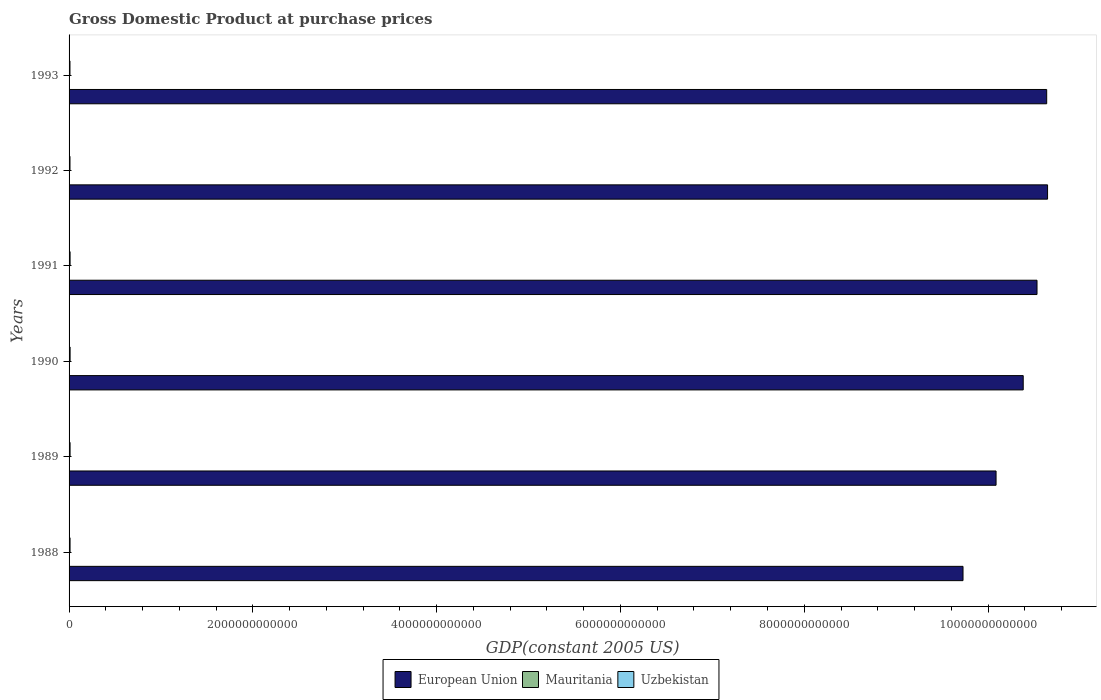Are the number of bars per tick equal to the number of legend labels?
Make the answer very short. Yes. Are the number of bars on each tick of the Y-axis equal?
Your response must be concise. Yes. How many bars are there on the 6th tick from the bottom?
Provide a short and direct response. 3. What is the GDP at purchase prices in European Union in 1988?
Ensure brevity in your answer.  9.73e+12. Across all years, what is the maximum GDP at purchase prices in European Union?
Give a very brief answer. 1.06e+13. Across all years, what is the minimum GDP at purchase prices in European Union?
Offer a very short reply. 9.73e+12. In which year was the GDP at purchase prices in Uzbekistan maximum?
Your answer should be very brief. 1990. What is the total GDP at purchase prices in European Union in the graph?
Keep it short and to the point. 6.20e+13. What is the difference between the GDP at purchase prices in European Union in 1989 and that in 1993?
Give a very brief answer. -5.51e+11. What is the difference between the GDP at purchase prices in Mauritania in 1990 and the GDP at purchase prices in European Union in 1993?
Your answer should be compact. -1.06e+13. What is the average GDP at purchase prices in European Union per year?
Offer a very short reply. 1.03e+13. In the year 1992, what is the difference between the GDP at purchase prices in European Union and GDP at purchase prices in Mauritania?
Provide a succinct answer. 1.06e+13. In how many years, is the GDP at purchase prices in European Union greater than 1200000000000 US$?
Make the answer very short. 6. What is the ratio of the GDP at purchase prices in Uzbekistan in 1990 to that in 1992?
Keep it short and to the point. 1.13. Is the GDP at purchase prices in Uzbekistan in 1988 less than that in 1992?
Your response must be concise. No. Is the difference between the GDP at purchase prices in European Union in 1991 and 1992 greater than the difference between the GDP at purchase prices in Mauritania in 1991 and 1992?
Offer a terse response. No. What is the difference between the highest and the second highest GDP at purchase prices in European Union?
Provide a short and direct response. 9.57e+09. What is the difference between the highest and the lowest GDP at purchase prices in Uzbekistan?
Make the answer very short. 1.53e+09. Is the sum of the GDP at purchase prices in Uzbekistan in 1988 and 1990 greater than the maximum GDP at purchase prices in Mauritania across all years?
Ensure brevity in your answer.  Yes. What does the 1st bar from the top in 1988 represents?
Your response must be concise. Uzbekistan. What does the 1st bar from the bottom in 1988 represents?
Ensure brevity in your answer.  European Union. Are all the bars in the graph horizontal?
Your response must be concise. Yes. How many years are there in the graph?
Your answer should be compact. 6. What is the difference between two consecutive major ticks on the X-axis?
Your answer should be compact. 2.00e+12. Where does the legend appear in the graph?
Provide a succinct answer. Bottom center. How are the legend labels stacked?
Your answer should be compact. Horizontal. What is the title of the graph?
Your response must be concise. Gross Domestic Product at purchase prices. What is the label or title of the X-axis?
Make the answer very short. GDP(constant 2005 US). What is the label or title of the Y-axis?
Offer a very short reply. Years. What is the GDP(constant 2005 US) in European Union in 1988?
Your answer should be very brief. 9.73e+12. What is the GDP(constant 2005 US) of Mauritania in 1988?
Offer a very short reply. 1.29e+09. What is the GDP(constant 2005 US) of Uzbekistan in 1988?
Your answer should be compact. 1.07e+1. What is the GDP(constant 2005 US) of European Union in 1989?
Ensure brevity in your answer.  1.01e+13. What is the GDP(constant 2005 US) in Mauritania in 1989?
Give a very brief answer. 1.36e+09. What is the GDP(constant 2005 US) of Uzbekistan in 1989?
Give a very brief answer. 1.10e+1. What is the GDP(constant 2005 US) in European Union in 1990?
Offer a terse response. 1.04e+13. What is the GDP(constant 2005 US) of Mauritania in 1990?
Make the answer very short. 1.33e+09. What is the GDP(constant 2005 US) of Uzbekistan in 1990?
Offer a terse response. 1.12e+1. What is the GDP(constant 2005 US) in European Union in 1991?
Provide a succinct answer. 1.05e+13. What is the GDP(constant 2005 US) of Mauritania in 1991?
Offer a terse response. 1.36e+09. What is the GDP(constant 2005 US) of Uzbekistan in 1991?
Offer a very short reply. 1.12e+1. What is the GDP(constant 2005 US) in European Union in 1992?
Provide a succinct answer. 1.06e+13. What is the GDP(constant 2005 US) in Mauritania in 1992?
Provide a short and direct response. 1.38e+09. What is the GDP(constant 2005 US) in Uzbekistan in 1992?
Your answer should be very brief. 9.92e+09. What is the GDP(constant 2005 US) in European Union in 1993?
Your answer should be very brief. 1.06e+13. What is the GDP(constant 2005 US) of Mauritania in 1993?
Keep it short and to the point. 1.46e+09. What is the GDP(constant 2005 US) in Uzbekistan in 1993?
Provide a short and direct response. 9.69e+09. Across all years, what is the maximum GDP(constant 2005 US) of European Union?
Keep it short and to the point. 1.06e+13. Across all years, what is the maximum GDP(constant 2005 US) of Mauritania?
Make the answer very short. 1.46e+09. Across all years, what is the maximum GDP(constant 2005 US) in Uzbekistan?
Your response must be concise. 1.12e+1. Across all years, what is the minimum GDP(constant 2005 US) in European Union?
Ensure brevity in your answer.  9.73e+12. Across all years, what is the minimum GDP(constant 2005 US) in Mauritania?
Provide a succinct answer. 1.29e+09. Across all years, what is the minimum GDP(constant 2005 US) of Uzbekistan?
Offer a terse response. 9.69e+09. What is the total GDP(constant 2005 US) in European Union in the graph?
Provide a succinct answer. 6.20e+13. What is the total GDP(constant 2005 US) of Mauritania in the graph?
Your answer should be compact. 8.18e+09. What is the total GDP(constant 2005 US) of Uzbekistan in the graph?
Your answer should be very brief. 6.37e+1. What is the difference between the GDP(constant 2005 US) in European Union in 1988 and that in 1989?
Give a very brief answer. -3.60e+11. What is the difference between the GDP(constant 2005 US) of Mauritania in 1988 and that in 1989?
Your answer should be very brief. -6.18e+07. What is the difference between the GDP(constant 2005 US) of Uzbekistan in 1988 and that in 1989?
Your response must be concise. -3.31e+08. What is the difference between the GDP(constant 2005 US) of European Union in 1988 and that in 1990?
Your response must be concise. -6.55e+11. What is the difference between the GDP(constant 2005 US) of Mauritania in 1988 and that in 1990?
Provide a short and direct response. -3.78e+07. What is the difference between the GDP(constant 2005 US) in Uzbekistan in 1988 and that in 1990?
Your response must be concise. -5.08e+08. What is the difference between the GDP(constant 2005 US) of European Union in 1988 and that in 1991?
Your answer should be compact. -8.05e+11. What is the difference between the GDP(constant 2005 US) in Mauritania in 1988 and that in 1991?
Make the answer very short. -6.16e+07. What is the difference between the GDP(constant 2005 US) in Uzbekistan in 1988 and that in 1991?
Keep it short and to the point. -4.53e+08. What is the difference between the GDP(constant 2005 US) in European Union in 1988 and that in 1992?
Give a very brief answer. -9.20e+11. What is the difference between the GDP(constant 2005 US) of Mauritania in 1988 and that in 1992?
Your answer should be very brief. -8.70e+07. What is the difference between the GDP(constant 2005 US) in Uzbekistan in 1988 and that in 1992?
Offer a very short reply. 7.98e+08. What is the difference between the GDP(constant 2005 US) in European Union in 1988 and that in 1993?
Offer a terse response. -9.10e+11. What is the difference between the GDP(constant 2005 US) of Mauritania in 1988 and that in 1993?
Offer a very short reply. -1.68e+08. What is the difference between the GDP(constant 2005 US) in Uzbekistan in 1988 and that in 1993?
Provide a short and direct response. 1.03e+09. What is the difference between the GDP(constant 2005 US) in European Union in 1989 and that in 1990?
Offer a terse response. -2.95e+11. What is the difference between the GDP(constant 2005 US) in Mauritania in 1989 and that in 1990?
Your response must be concise. 2.40e+07. What is the difference between the GDP(constant 2005 US) of Uzbekistan in 1989 and that in 1990?
Your answer should be very brief. -1.77e+08. What is the difference between the GDP(constant 2005 US) in European Union in 1989 and that in 1991?
Offer a very short reply. -4.46e+11. What is the difference between the GDP(constant 2005 US) in Mauritania in 1989 and that in 1991?
Your answer should be compact. 2.02e+05. What is the difference between the GDP(constant 2005 US) of Uzbekistan in 1989 and that in 1991?
Your answer should be very brief. -1.22e+08. What is the difference between the GDP(constant 2005 US) of European Union in 1989 and that in 1992?
Provide a succinct answer. -5.60e+11. What is the difference between the GDP(constant 2005 US) in Mauritania in 1989 and that in 1992?
Offer a terse response. -2.52e+07. What is the difference between the GDP(constant 2005 US) in Uzbekistan in 1989 and that in 1992?
Give a very brief answer. 1.13e+09. What is the difference between the GDP(constant 2005 US) in European Union in 1989 and that in 1993?
Keep it short and to the point. -5.51e+11. What is the difference between the GDP(constant 2005 US) of Mauritania in 1989 and that in 1993?
Give a very brief answer. -1.06e+08. What is the difference between the GDP(constant 2005 US) in Uzbekistan in 1989 and that in 1993?
Your response must be concise. 1.36e+09. What is the difference between the GDP(constant 2005 US) of European Union in 1990 and that in 1991?
Ensure brevity in your answer.  -1.50e+11. What is the difference between the GDP(constant 2005 US) in Mauritania in 1990 and that in 1991?
Provide a short and direct response. -2.38e+07. What is the difference between the GDP(constant 2005 US) of Uzbekistan in 1990 and that in 1991?
Offer a terse response. 5.52e+07. What is the difference between the GDP(constant 2005 US) in European Union in 1990 and that in 1992?
Your response must be concise. -2.65e+11. What is the difference between the GDP(constant 2005 US) of Mauritania in 1990 and that in 1992?
Your answer should be compact. -4.92e+07. What is the difference between the GDP(constant 2005 US) of Uzbekistan in 1990 and that in 1992?
Offer a terse response. 1.31e+09. What is the difference between the GDP(constant 2005 US) of European Union in 1990 and that in 1993?
Provide a short and direct response. -2.55e+11. What is the difference between the GDP(constant 2005 US) in Mauritania in 1990 and that in 1993?
Give a very brief answer. -1.30e+08. What is the difference between the GDP(constant 2005 US) of Uzbekistan in 1990 and that in 1993?
Your answer should be very brief. 1.53e+09. What is the difference between the GDP(constant 2005 US) of European Union in 1991 and that in 1992?
Your answer should be compact. -1.15e+11. What is the difference between the GDP(constant 2005 US) of Mauritania in 1991 and that in 1992?
Provide a succinct answer. -2.54e+07. What is the difference between the GDP(constant 2005 US) in Uzbekistan in 1991 and that in 1992?
Provide a succinct answer. 1.25e+09. What is the difference between the GDP(constant 2005 US) of European Union in 1991 and that in 1993?
Keep it short and to the point. -1.05e+11. What is the difference between the GDP(constant 2005 US) in Mauritania in 1991 and that in 1993?
Offer a very short reply. -1.07e+08. What is the difference between the GDP(constant 2005 US) of Uzbekistan in 1991 and that in 1993?
Your response must be concise. 1.48e+09. What is the difference between the GDP(constant 2005 US) in European Union in 1992 and that in 1993?
Make the answer very short. 9.57e+09. What is the difference between the GDP(constant 2005 US) in Mauritania in 1992 and that in 1993?
Provide a succinct answer. -8.11e+07. What is the difference between the GDP(constant 2005 US) in Uzbekistan in 1992 and that in 1993?
Ensure brevity in your answer.  2.28e+08. What is the difference between the GDP(constant 2005 US) of European Union in 1988 and the GDP(constant 2005 US) of Mauritania in 1989?
Give a very brief answer. 9.73e+12. What is the difference between the GDP(constant 2005 US) of European Union in 1988 and the GDP(constant 2005 US) of Uzbekistan in 1989?
Keep it short and to the point. 9.72e+12. What is the difference between the GDP(constant 2005 US) in Mauritania in 1988 and the GDP(constant 2005 US) in Uzbekistan in 1989?
Make the answer very short. -9.75e+09. What is the difference between the GDP(constant 2005 US) in European Union in 1988 and the GDP(constant 2005 US) in Mauritania in 1990?
Give a very brief answer. 9.73e+12. What is the difference between the GDP(constant 2005 US) in European Union in 1988 and the GDP(constant 2005 US) in Uzbekistan in 1990?
Give a very brief answer. 9.72e+12. What is the difference between the GDP(constant 2005 US) of Mauritania in 1988 and the GDP(constant 2005 US) of Uzbekistan in 1990?
Offer a terse response. -9.93e+09. What is the difference between the GDP(constant 2005 US) in European Union in 1988 and the GDP(constant 2005 US) in Mauritania in 1991?
Your response must be concise. 9.73e+12. What is the difference between the GDP(constant 2005 US) of European Union in 1988 and the GDP(constant 2005 US) of Uzbekistan in 1991?
Your answer should be very brief. 9.72e+12. What is the difference between the GDP(constant 2005 US) of Mauritania in 1988 and the GDP(constant 2005 US) of Uzbekistan in 1991?
Your response must be concise. -9.87e+09. What is the difference between the GDP(constant 2005 US) in European Union in 1988 and the GDP(constant 2005 US) in Mauritania in 1992?
Offer a terse response. 9.73e+12. What is the difference between the GDP(constant 2005 US) in European Union in 1988 and the GDP(constant 2005 US) in Uzbekistan in 1992?
Give a very brief answer. 9.72e+12. What is the difference between the GDP(constant 2005 US) in Mauritania in 1988 and the GDP(constant 2005 US) in Uzbekistan in 1992?
Keep it short and to the point. -8.62e+09. What is the difference between the GDP(constant 2005 US) in European Union in 1988 and the GDP(constant 2005 US) in Mauritania in 1993?
Your answer should be compact. 9.73e+12. What is the difference between the GDP(constant 2005 US) in European Union in 1988 and the GDP(constant 2005 US) in Uzbekistan in 1993?
Your answer should be compact. 9.72e+12. What is the difference between the GDP(constant 2005 US) in Mauritania in 1988 and the GDP(constant 2005 US) in Uzbekistan in 1993?
Your answer should be compact. -8.39e+09. What is the difference between the GDP(constant 2005 US) in European Union in 1989 and the GDP(constant 2005 US) in Mauritania in 1990?
Your answer should be compact. 1.01e+13. What is the difference between the GDP(constant 2005 US) of European Union in 1989 and the GDP(constant 2005 US) of Uzbekistan in 1990?
Make the answer very short. 1.01e+13. What is the difference between the GDP(constant 2005 US) in Mauritania in 1989 and the GDP(constant 2005 US) in Uzbekistan in 1990?
Ensure brevity in your answer.  -9.87e+09. What is the difference between the GDP(constant 2005 US) in European Union in 1989 and the GDP(constant 2005 US) in Mauritania in 1991?
Offer a terse response. 1.01e+13. What is the difference between the GDP(constant 2005 US) of European Union in 1989 and the GDP(constant 2005 US) of Uzbekistan in 1991?
Ensure brevity in your answer.  1.01e+13. What is the difference between the GDP(constant 2005 US) of Mauritania in 1989 and the GDP(constant 2005 US) of Uzbekistan in 1991?
Your response must be concise. -9.81e+09. What is the difference between the GDP(constant 2005 US) of European Union in 1989 and the GDP(constant 2005 US) of Mauritania in 1992?
Your answer should be very brief. 1.01e+13. What is the difference between the GDP(constant 2005 US) in European Union in 1989 and the GDP(constant 2005 US) in Uzbekistan in 1992?
Ensure brevity in your answer.  1.01e+13. What is the difference between the GDP(constant 2005 US) of Mauritania in 1989 and the GDP(constant 2005 US) of Uzbekistan in 1992?
Provide a short and direct response. -8.56e+09. What is the difference between the GDP(constant 2005 US) in European Union in 1989 and the GDP(constant 2005 US) in Mauritania in 1993?
Offer a terse response. 1.01e+13. What is the difference between the GDP(constant 2005 US) of European Union in 1989 and the GDP(constant 2005 US) of Uzbekistan in 1993?
Keep it short and to the point. 1.01e+13. What is the difference between the GDP(constant 2005 US) in Mauritania in 1989 and the GDP(constant 2005 US) in Uzbekistan in 1993?
Your answer should be very brief. -8.33e+09. What is the difference between the GDP(constant 2005 US) in European Union in 1990 and the GDP(constant 2005 US) in Mauritania in 1991?
Offer a very short reply. 1.04e+13. What is the difference between the GDP(constant 2005 US) of European Union in 1990 and the GDP(constant 2005 US) of Uzbekistan in 1991?
Make the answer very short. 1.04e+13. What is the difference between the GDP(constant 2005 US) in Mauritania in 1990 and the GDP(constant 2005 US) in Uzbekistan in 1991?
Offer a very short reply. -9.83e+09. What is the difference between the GDP(constant 2005 US) in European Union in 1990 and the GDP(constant 2005 US) in Mauritania in 1992?
Offer a terse response. 1.04e+13. What is the difference between the GDP(constant 2005 US) of European Union in 1990 and the GDP(constant 2005 US) of Uzbekistan in 1992?
Give a very brief answer. 1.04e+13. What is the difference between the GDP(constant 2005 US) in Mauritania in 1990 and the GDP(constant 2005 US) in Uzbekistan in 1992?
Ensure brevity in your answer.  -8.58e+09. What is the difference between the GDP(constant 2005 US) in European Union in 1990 and the GDP(constant 2005 US) in Mauritania in 1993?
Keep it short and to the point. 1.04e+13. What is the difference between the GDP(constant 2005 US) in European Union in 1990 and the GDP(constant 2005 US) in Uzbekistan in 1993?
Keep it short and to the point. 1.04e+13. What is the difference between the GDP(constant 2005 US) of Mauritania in 1990 and the GDP(constant 2005 US) of Uzbekistan in 1993?
Your answer should be very brief. -8.36e+09. What is the difference between the GDP(constant 2005 US) in European Union in 1991 and the GDP(constant 2005 US) in Mauritania in 1992?
Your response must be concise. 1.05e+13. What is the difference between the GDP(constant 2005 US) of European Union in 1991 and the GDP(constant 2005 US) of Uzbekistan in 1992?
Your answer should be very brief. 1.05e+13. What is the difference between the GDP(constant 2005 US) in Mauritania in 1991 and the GDP(constant 2005 US) in Uzbekistan in 1992?
Your answer should be very brief. -8.56e+09. What is the difference between the GDP(constant 2005 US) of European Union in 1991 and the GDP(constant 2005 US) of Mauritania in 1993?
Offer a terse response. 1.05e+13. What is the difference between the GDP(constant 2005 US) in European Union in 1991 and the GDP(constant 2005 US) in Uzbekistan in 1993?
Keep it short and to the point. 1.05e+13. What is the difference between the GDP(constant 2005 US) in Mauritania in 1991 and the GDP(constant 2005 US) in Uzbekistan in 1993?
Provide a succinct answer. -8.33e+09. What is the difference between the GDP(constant 2005 US) in European Union in 1992 and the GDP(constant 2005 US) in Mauritania in 1993?
Keep it short and to the point. 1.06e+13. What is the difference between the GDP(constant 2005 US) in European Union in 1992 and the GDP(constant 2005 US) in Uzbekistan in 1993?
Your answer should be compact. 1.06e+13. What is the difference between the GDP(constant 2005 US) in Mauritania in 1992 and the GDP(constant 2005 US) in Uzbekistan in 1993?
Provide a short and direct response. -8.31e+09. What is the average GDP(constant 2005 US) in European Union per year?
Ensure brevity in your answer.  1.03e+13. What is the average GDP(constant 2005 US) in Mauritania per year?
Your answer should be compact. 1.36e+09. What is the average GDP(constant 2005 US) of Uzbekistan per year?
Offer a terse response. 1.06e+1. In the year 1988, what is the difference between the GDP(constant 2005 US) in European Union and GDP(constant 2005 US) in Mauritania?
Make the answer very short. 9.73e+12. In the year 1988, what is the difference between the GDP(constant 2005 US) in European Union and GDP(constant 2005 US) in Uzbekistan?
Offer a terse response. 9.72e+12. In the year 1988, what is the difference between the GDP(constant 2005 US) in Mauritania and GDP(constant 2005 US) in Uzbekistan?
Offer a very short reply. -9.42e+09. In the year 1989, what is the difference between the GDP(constant 2005 US) of European Union and GDP(constant 2005 US) of Mauritania?
Your answer should be very brief. 1.01e+13. In the year 1989, what is the difference between the GDP(constant 2005 US) of European Union and GDP(constant 2005 US) of Uzbekistan?
Keep it short and to the point. 1.01e+13. In the year 1989, what is the difference between the GDP(constant 2005 US) in Mauritania and GDP(constant 2005 US) in Uzbekistan?
Offer a very short reply. -9.69e+09. In the year 1990, what is the difference between the GDP(constant 2005 US) in European Union and GDP(constant 2005 US) in Mauritania?
Provide a short and direct response. 1.04e+13. In the year 1990, what is the difference between the GDP(constant 2005 US) in European Union and GDP(constant 2005 US) in Uzbekistan?
Make the answer very short. 1.04e+13. In the year 1990, what is the difference between the GDP(constant 2005 US) in Mauritania and GDP(constant 2005 US) in Uzbekistan?
Make the answer very short. -9.89e+09. In the year 1991, what is the difference between the GDP(constant 2005 US) in European Union and GDP(constant 2005 US) in Mauritania?
Keep it short and to the point. 1.05e+13. In the year 1991, what is the difference between the GDP(constant 2005 US) in European Union and GDP(constant 2005 US) in Uzbekistan?
Give a very brief answer. 1.05e+13. In the year 1991, what is the difference between the GDP(constant 2005 US) of Mauritania and GDP(constant 2005 US) of Uzbekistan?
Keep it short and to the point. -9.81e+09. In the year 1992, what is the difference between the GDP(constant 2005 US) of European Union and GDP(constant 2005 US) of Mauritania?
Provide a succinct answer. 1.06e+13. In the year 1992, what is the difference between the GDP(constant 2005 US) in European Union and GDP(constant 2005 US) in Uzbekistan?
Ensure brevity in your answer.  1.06e+13. In the year 1992, what is the difference between the GDP(constant 2005 US) of Mauritania and GDP(constant 2005 US) of Uzbekistan?
Your response must be concise. -8.53e+09. In the year 1993, what is the difference between the GDP(constant 2005 US) in European Union and GDP(constant 2005 US) in Mauritania?
Your response must be concise. 1.06e+13. In the year 1993, what is the difference between the GDP(constant 2005 US) of European Union and GDP(constant 2005 US) of Uzbekistan?
Provide a short and direct response. 1.06e+13. In the year 1993, what is the difference between the GDP(constant 2005 US) in Mauritania and GDP(constant 2005 US) in Uzbekistan?
Your answer should be very brief. -8.23e+09. What is the ratio of the GDP(constant 2005 US) of European Union in 1988 to that in 1989?
Make the answer very short. 0.96. What is the ratio of the GDP(constant 2005 US) of Mauritania in 1988 to that in 1989?
Your response must be concise. 0.95. What is the ratio of the GDP(constant 2005 US) in Uzbekistan in 1988 to that in 1989?
Offer a very short reply. 0.97. What is the ratio of the GDP(constant 2005 US) of European Union in 1988 to that in 1990?
Give a very brief answer. 0.94. What is the ratio of the GDP(constant 2005 US) in Mauritania in 1988 to that in 1990?
Make the answer very short. 0.97. What is the ratio of the GDP(constant 2005 US) in Uzbekistan in 1988 to that in 1990?
Provide a short and direct response. 0.95. What is the ratio of the GDP(constant 2005 US) of European Union in 1988 to that in 1991?
Your answer should be compact. 0.92. What is the ratio of the GDP(constant 2005 US) in Mauritania in 1988 to that in 1991?
Keep it short and to the point. 0.95. What is the ratio of the GDP(constant 2005 US) in Uzbekistan in 1988 to that in 1991?
Your answer should be compact. 0.96. What is the ratio of the GDP(constant 2005 US) of European Union in 1988 to that in 1992?
Offer a very short reply. 0.91. What is the ratio of the GDP(constant 2005 US) in Mauritania in 1988 to that in 1992?
Your answer should be compact. 0.94. What is the ratio of the GDP(constant 2005 US) in Uzbekistan in 1988 to that in 1992?
Your response must be concise. 1.08. What is the ratio of the GDP(constant 2005 US) of European Union in 1988 to that in 1993?
Make the answer very short. 0.91. What is the ratio of the GDP(constant 2005 US) of Mauritania in 1988 to that in 1993?
Keep it short and to the point. 0.89. What is the ratio of the GDP(constant 2005 US) of Uzbekistan in 1988 to that in 1993?
Your answer should be compact. 1.11. What is the ratio of the GDP(constant 2005 US) of European Union in 1989 to that in 1990?
Offer a terse response. 0.97. What is the ratio of the GDP(constant 2005 US) in Uzbekistan in 1989 to that in 1990?
Provide a short and direct response. 0.98. What is the ratio of the GDP(constant 2005 US) of European Union in 1989 to that in 1991?
Your response must be concise. 0.96. What is the ratio of the GDP(constant 2005 US) of Mauritania in 1989 to that in 1991?
Offer a terse response. 1. What is the ratio of the GDP(constant 2005 US) in Mauritania in 1989 to that in 1992?
Provide a short and direct response. 0.98. What is the ratio of the GDP(constant 2005 US) in Uzbekistan in 1989 to that in 1992?
Give a very brief answer. 1.11. What is the ratio of the GDP(constant 2005 US) of European Union in 1989 to that in 1993?
Offer a terse response. 0.95. What is the ratio of the GDP(constant 2005 US) in Mauritania in 1989 to that in 1993?
Keep it short and to the point. 0.93. What is the ratio of the GDP(constant 2005 US) in Uzbekistan in 1989 to that in 1993?
Your answer should be compact. 1.14. What is the ratio of the GDP(constant 2005 US) in European Union in 1990 to that in 1991?
Give a very brief answer. 0.99. What is the ratio of the GDP(constant 2005 US) of Mauritania in 1990 to that in 1991?
Provide a succinct answer. 0.98. What is the ratio of the GDP(constant 2005 US) of European Union in 1990 to that in 1992?
Your answer should be compact. 0.98. What is the ratio of the GDP(constant 2005 US) in Mauritania in 1990 to that in 1992?
Offer a terse response. 0.96. What is the ratio of the GDP(constant 2005 US) in Uzbekistan in 1990 to that in 1992?
Your answer should be compact. 1.13. What is the ratio of the GDP(constant 2005 US) of European Union in 1990 to that in 1993?
Your answer should be compact. 0.98. What is the ratio of the GDP(constant 2005 US) of Mauritania in 1990 to that in 1993?
Keep it short and to the point. 0.91. What is the ratio of the GDP(constant 2005 US) in Uzbekistan in 1990 to that in 1993?
Provide a succinct answer. 1.16. What is the ratio of the GDP(constant 2005 US) in European Union in 1991 to that in 1992?
Offer a very short reply. 0.99. What is the ratio of the GDP(constant 2005 US) of Mauritania in 1991 to that in 1992?
Offer a very short reply. 0.98. What is the ratio of the GDP(constant 2005 US) in Uzbekistan in 1991 to that in 1992?
Give a very brief answer. 1.13. What is the ratio of the GDP(constant 2005 US) of European Union in 1991 to that in 1993?
Offer a very short reply. 0.99. What is the ratio of the GDP(constant 2005 US) in Mauritania in 1991 to that in 1993?
Your response must be concise. 0.93. What is the ratio of the GDP(constant 2005 US) of Uzbekistan in 1991 to that in 1993?
Give a very brief answer. 1.15. What is the ratio of the GDP(constant 2005 US) of European Union in 1992 to that in 1993?
Your answer should be very brief. 1. What is the ratio of the GDP(constant 2005 US) in Mauritania in 1992 to that in 1993?
Your answer should be compact. 0.94. What is the ratio of the GDP(constant 2005 US) in Uzbekistan in 1992 to that in 1993?
Make the answer very short. 1.02. What is the difference between the highest and the second highest GDP(constant 2005 US) in European Union?
Keep it short and to the point. 9.57e+09. What is the difference between the highest and the second highest GDP(constant 2005 US) in Mauritania?
Your answer should be compact. 8.11e+07. What is the difference between the highest and the second highest GDP(constant 2005 US) of Uzbekistan?
Offer a very short reply. 5.52e+07. What is the difference between the highest and the lowest GDP(constant 2005 US) of European Union?
Provide a short and direct response. 9.20e+11. What is the difference between the highest and the lowest GDP(constant 2005 US) of Mauritania?
Give a very brief answer. 1.68e+08. What is the difference between the highest and the lowest GDP(constant 2005 US) of Uzbekistan?
Your answer should be very brief. 1.53e+09. 